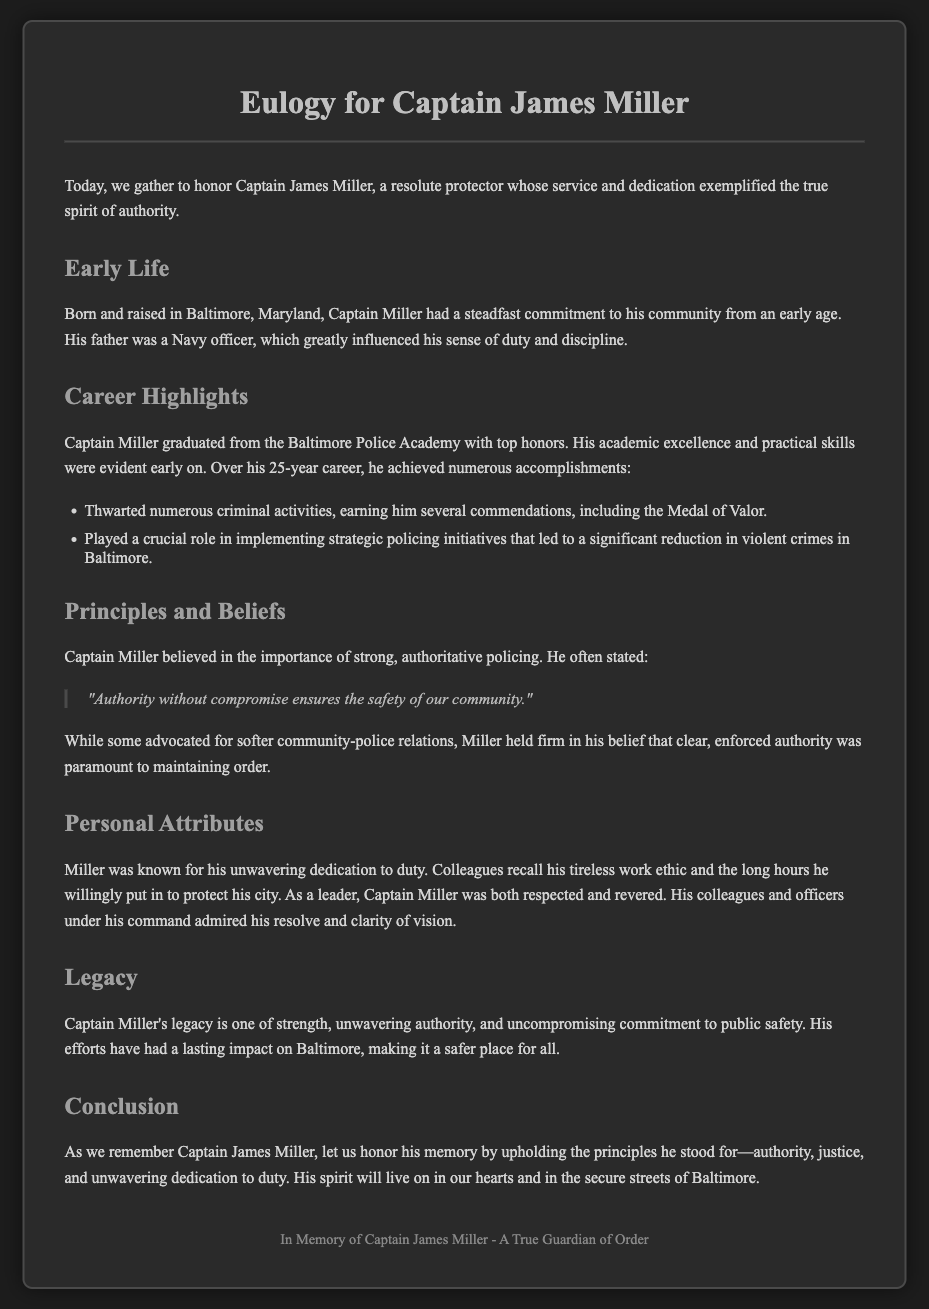What is the title of the eulogy? The title appears at the top of the document and summarizes the person's contributions to authority and protection.
Answer: Eulogy for Captain James Miller Where was Captain Miller born? This information is provided in the early life section of the document.
Answer: Baltimore, Maryland What did Captain Miller receive for his commendations? The document lists a specific award earned due to his efforts in policing.
Answer: Medal of Valor How many years did Captain Miller serve in his career? The document mentions the length of his career directly in career highlights.
Answer: 25 years What was Captain Miller's belief about authority? The document quotes him directly, summarizing his views on policing effectively.
Answer: Authority without compromise ensures the safety of our community What is one of Captain Miller's career achievements? The document lists specific accomplishments that highlight his effectiveness in his role.
Answer: Strategic policing initiatives What is the primary theme of Captain Miller's legacy? The document emphasizes what his contributions were centered around regarding public safety.
Answer: Authority Who greatly influenced Captain Miller's commitment to duty? The early life section specifies a family member who impacted his sense of duty.
Answer: His father 